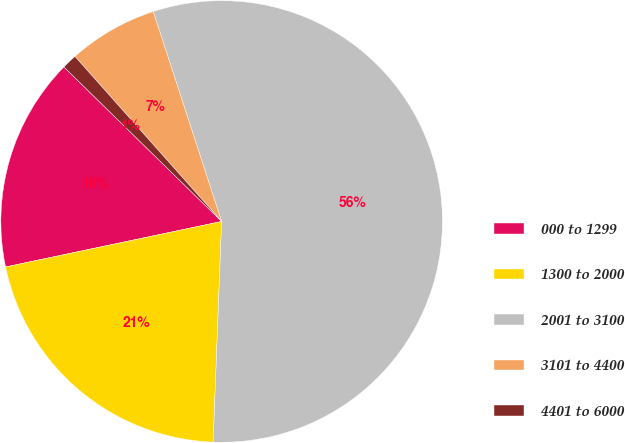<chart> <loc_0><loc_0><loc_500><loc_500><pie_chart><fcel>000 to 1299<fcel>1300 to 2000<fcel>2001 to 3100<fcel>3101 to 4400<fcel>4401 to 6000<nl><fcel>15.64%<fcel>21.09%<fcel>55.63%<fcel>6.55%<fcel>1.1%<nl></chart> 